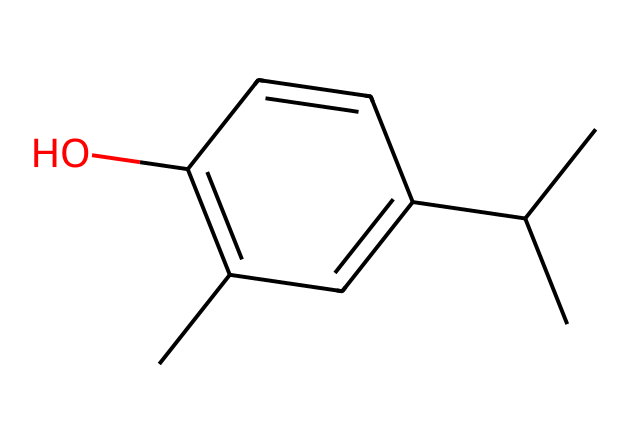What is the molecular formula of thymol? To find the molecular formula, we count the number of each type of atom in the SMILES representation. The structure contains 10 carbon atoms, 14 hydrogen atoms, and 1 oxygen atom. Thus, the molecular formula is C10H14O.
Answer: C10H14O How many rings are present in the structure of thymol? By analyzing the SMILES, we note that a ring is indicated by the number associated with the carbon atoms. The 'C1' and 'C' following 'C1' indicate the presence of a single ring. Therefore, there is one ring in thymol.
Answer: 1 What type of functional group is present in thymol? The hydroxyl group (-OH) is present in the structure, indicated by the 'O' connected to a carbon, making it a phenolic compound due to both the aromatic ring and the hydroxyl group.
Answer: hydroxyl group Based on its structure, is thymol likely to be hydrophilic or hydrophobic? The presence of the hydroxyl group makes thymol more hydrophilic, as hydroxyl groups interact well with water due to hydrogen bonding. The overall structure of the aromatic ring contributes but does not outweigh the influence of the hydroxyl group.
Answer: hydrophilic What type of compound is thymol classified as? Given its chemical structure with an aromatic ring and a hydroxyl functional group, thymol is classified as a phenol.
Answer: phenol 